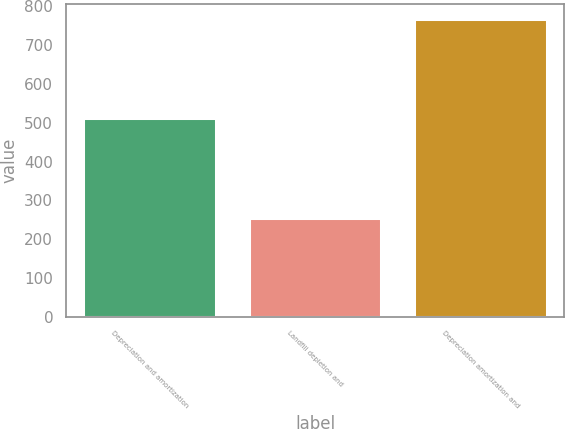Convert chart. <chart><loc_0><loc_0><loc_500><loc_500><bar_chart><fcel>Depreciation and amortization<fcel>Landfill depletion and<fcel>Depreciation amortization and<nl><fcel>511.4<fcel>255.5<fcel>766.9<nl></chart> 